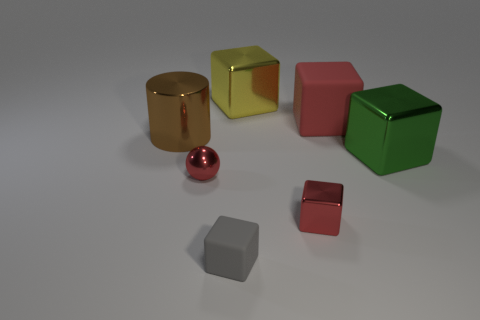What shapes can you identify in the image? In the image, you can see a variety of geometric shapes which include cubes, a cylinder, and a sphere. 